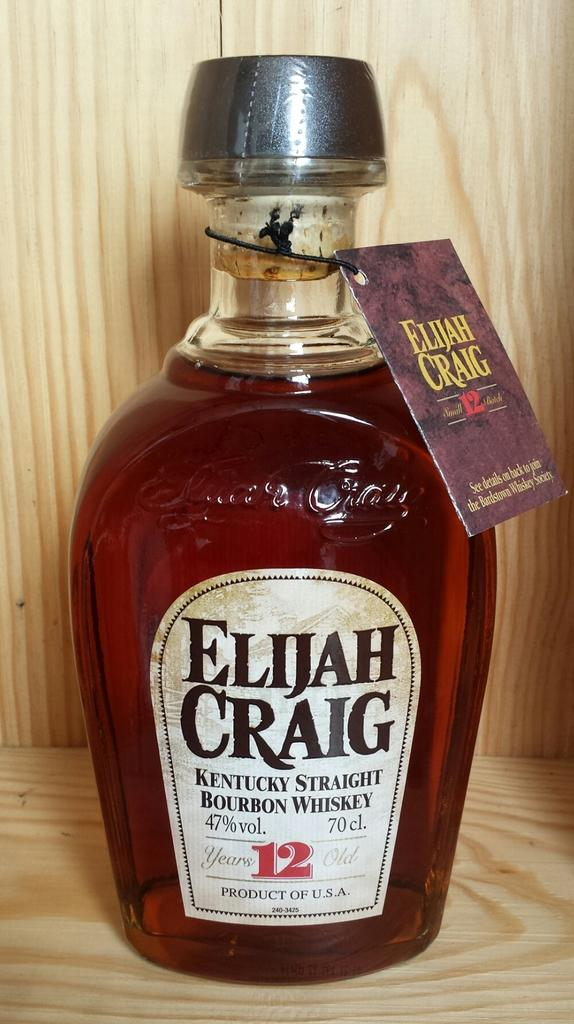<image>
Describe the image concisely. A bottle of bourbon whiskey called Elijah Craig 